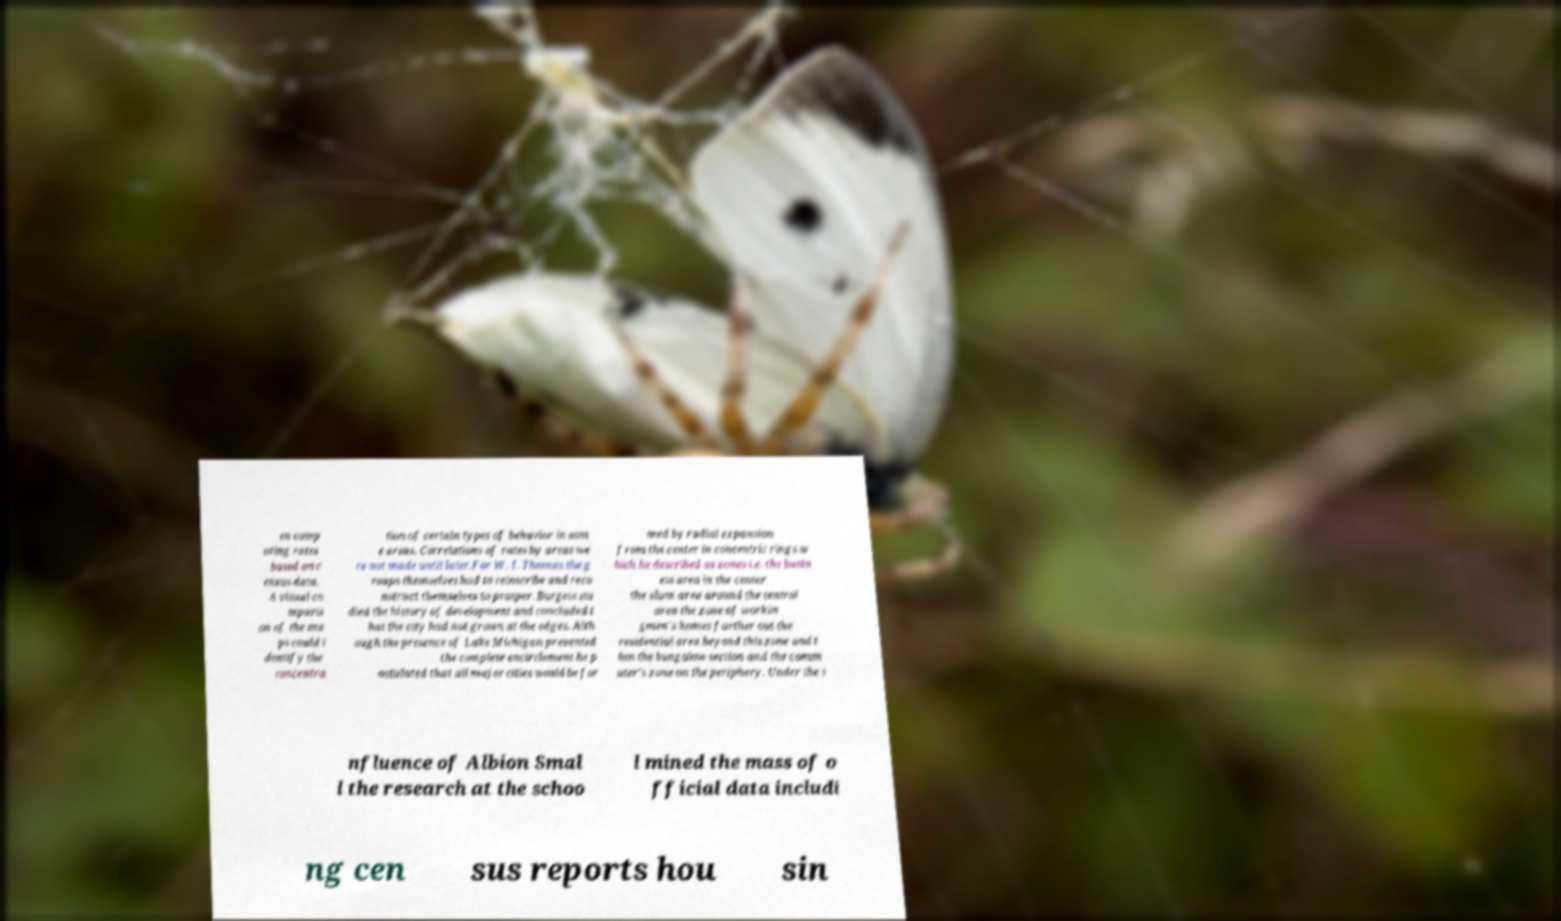I need the written content from this picture converted into text. Can you do that? en comp uting rates based on c ensus data. A visual co mparis on of the ma ps could i dentify the concentra tion of certain types of behavior in som e areas. Correlations of rates by areas we re not made until later.For W. I. Thomas the g roups themselves had to reinscribe and reco nstruct themselves to prosper. Burgess stu died the history of development and concluded t hat the city had not grown at the edges. Alth ough the presence of Lake Michigan prevented the complete encirclement he p ostulated that all major cities would be for med by radial expansion from the center in concentric rings w hich he described as zones i.e. the busin ess area in the center the slum area around the central area the zone of workin gmen's homes farther out the residential area beyond this zone and t hen the bungalow section and the comm uter's zone on the periphery. Under the i nfluence of Albion Smal l the research at the schoo l mined the mass of o fficial data includi ng cen sus reports hou sin 